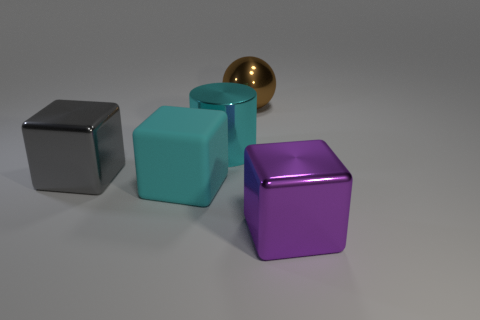Subtract all large gray metal blocks. How many blocks are left? 2 Add 1 big matte cubes. How many objects exist? 6 Subtract all purple blocks. How many blocks are left? 2 Subtract all balls. How many objects are left? 4 Add 4 purple things. How many purple things are left? 5 Add 5 cyan rubber cylinders. How many cyan rubber cylinders exist? 5 Subtract 1 cyan cylinders. How many objects are left? 4 Subtract 1 blocks. How many blocks are left? 2 Subtract all gray cubes. Subtract all brown cylinders. How many cubes are left? 2 Subtract all matte blocks. Subtract all big purple metallic blocks. How many objects are left? 3 